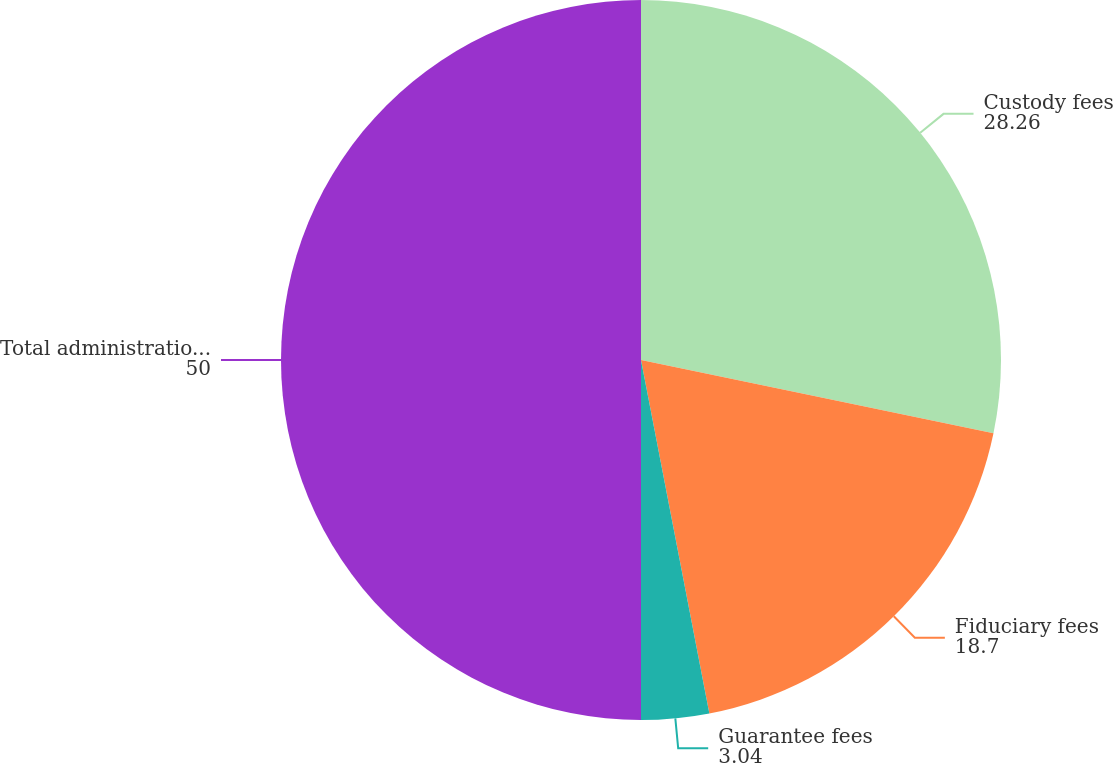Convert chart. <chart><loc_0><loc_0><loc_500><loc_500><pie_chart><fcel>Custody fees<fcel>Fiduciary fees<fcel>Guarantee fees<fcel>Total administration and other<nl><fcel>28.26%<fcel>18.7%<fcel>3.04%<fcel>50.0%<nl></chart> 